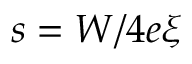<formula> <loc_0><loc_0><loc_500><loc_500>s = W / 4 e \xi</formula> 